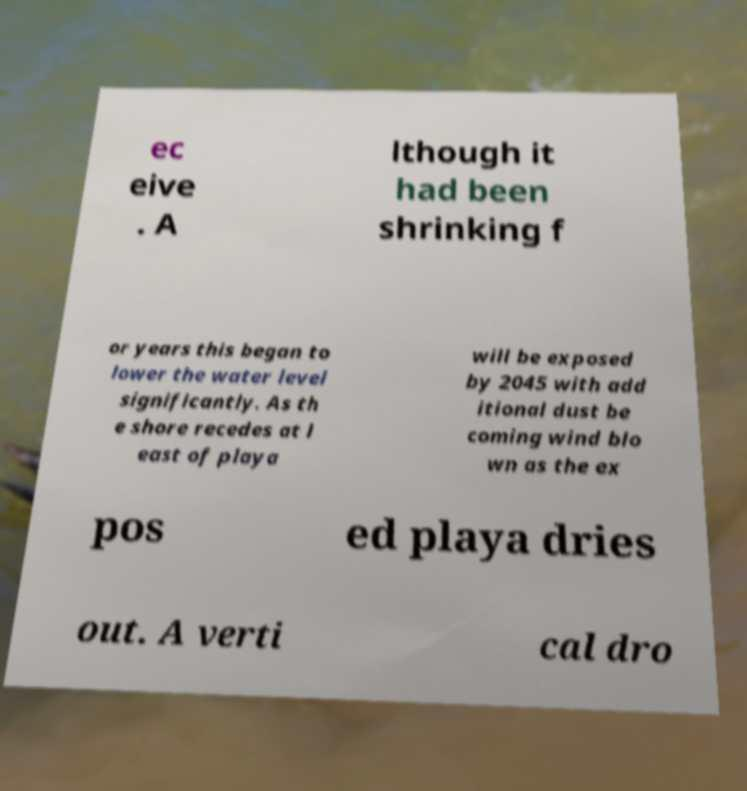Please read and relay the text visible in this image. What does it say? ec eive . A lthough it had been shrinking f or years this began to lower the water level significantly. As th e shore recedes at l east of playa will be exposed by 2045 with add itional dust be coming wind blo wn as the ex pos ed playa dries out. A verti cal dro 